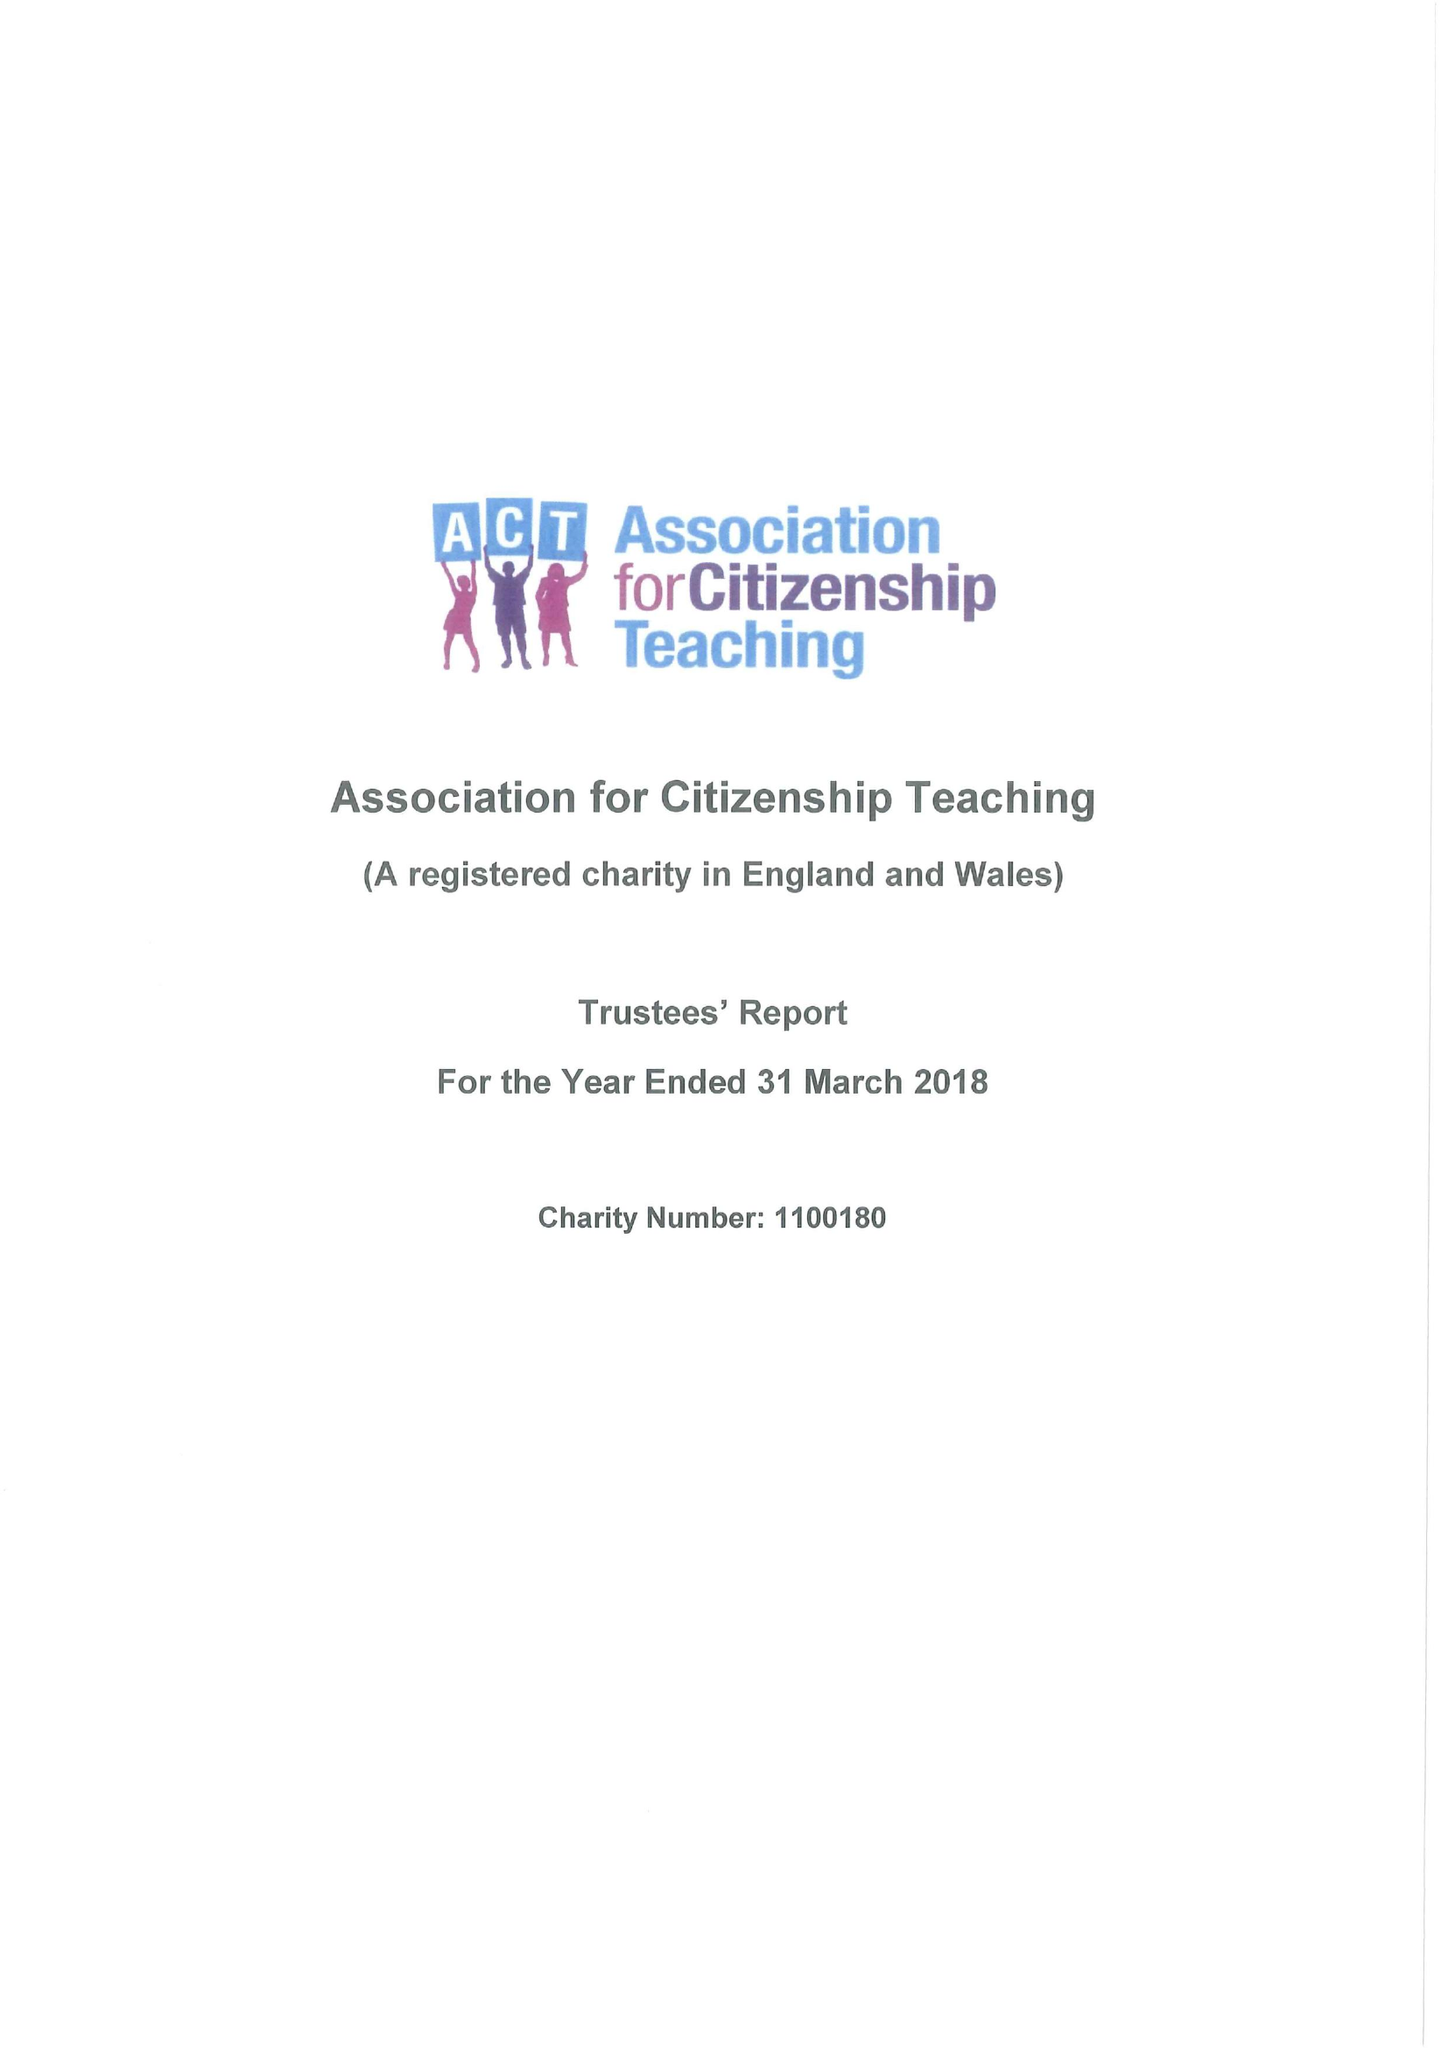What is the value for the spending_annually_in_british_pounds?
Answer the question using a single word or phrase. 172804.00 